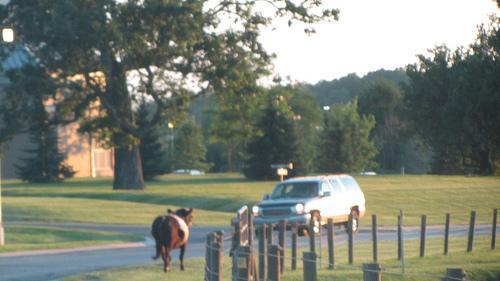How many animals are in the photo?
Give a very brief answer. 1. How many vehicles are in the picture?
Give a very brief answer. 1. How many buildings are in the scene?
Give a very brief answer. 1. 